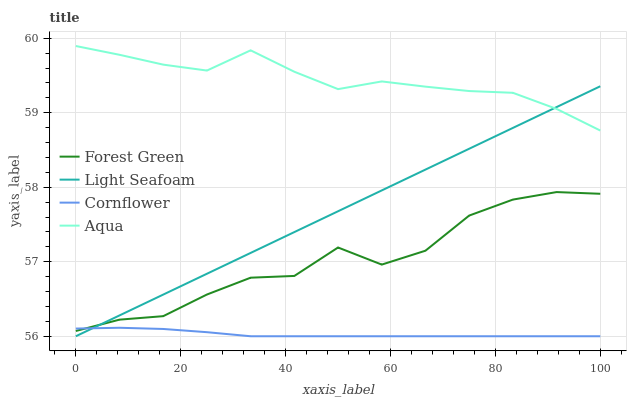Does Cornflower have the minimum area under the curve?
Answer yes or no. Yes. Does Aqua have the maximum area under the curve?
Answer yes or no. Yes. Does Forest Green have the minimum area under the curve?
Answer yes or no. No. Does Forest Green have the maximum area under the curve?
Answer yes or no. No. Is Light Seafoam the smoothest?
Answer yes or no. Yes. Is Forest Green the roughest?
Answer yes or no. Yes. Is Forest Green the smoothest?
Answer yes or no. No. Is Light Seafoam the roughest?
Answer yes or no. No. Does Forest Green have the lowest value?
Answer yes or no. No. Does Aqua have the highest value?
Answer yes or no. Yes. Does Forest Green have the highest value?
Answer yes or no. No. Is Cornflower less than Aqua?
Answer yes or no. Yes. Is Aqua greater than Cornflower?
Answer yes or no. Yes. Does Cornflower intersect Light Seafoam?
Answer yes or no. Yes. Is Cornflower less than Light Seafoam?
Answer yes or no. No. Is Cornflower greater than Light Seafoam?
Answer yes or no. No. Does Cornflower intersect Aqua?
Answer yes or no. No. 